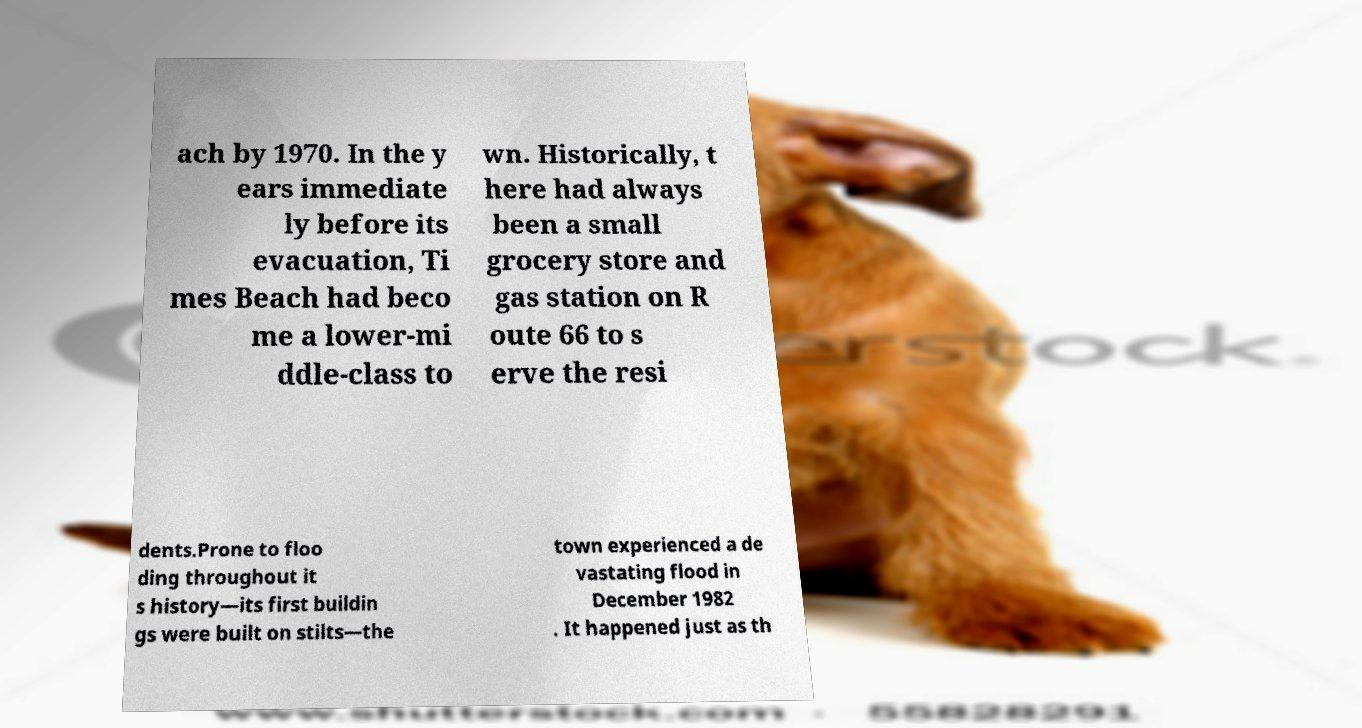What messages or text are displayed in this image? I need them in a readable, typed format. ach by 1970. In the y ears immediate ly before its evacuation, Ti mes Beach had beco me a lower-mi ddle-class to wn. Historically, t here had always been a small grocery store and gas station on R oute 66 to s erve the resi dents.Prone to floo ding throughout it s history—its first buildin gs were built on stilts—the town experienced a de vastating flood in December 1982 . It happened just as th 